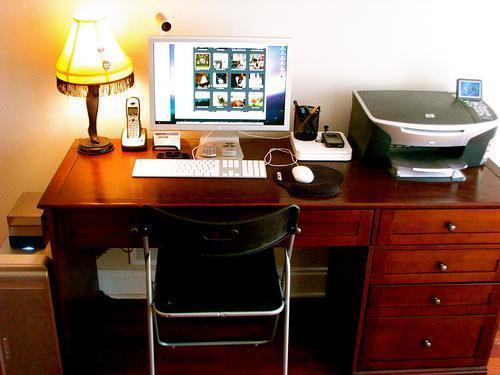How many desks are in this picture?
Give a very brief answer. 1. How many chairs are in the photo?
Give a very brief answer. 1. How many zebras are in this picture?
Give a very brief answer. 0. 